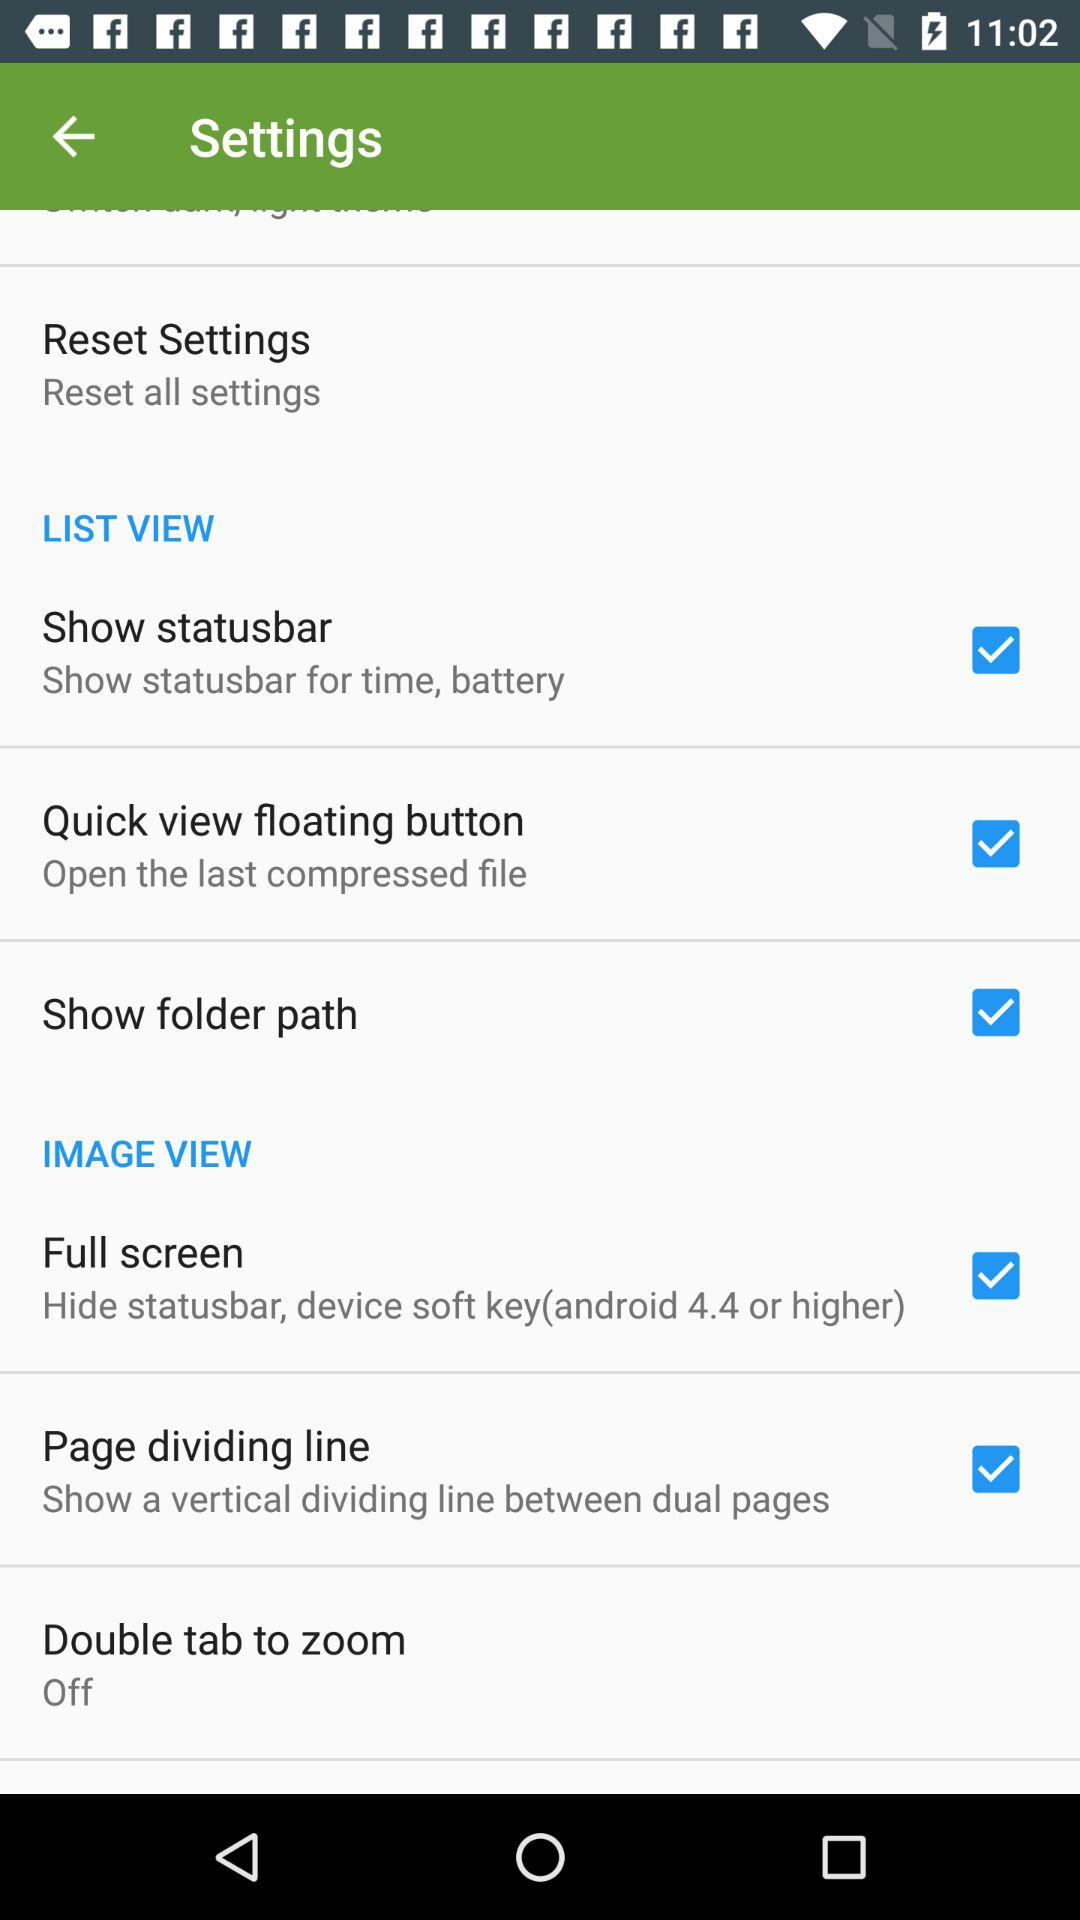Is "IMAGE VIEW" on or off?
When the provided information is insufficient, respond with <no answer>. <no answer> 